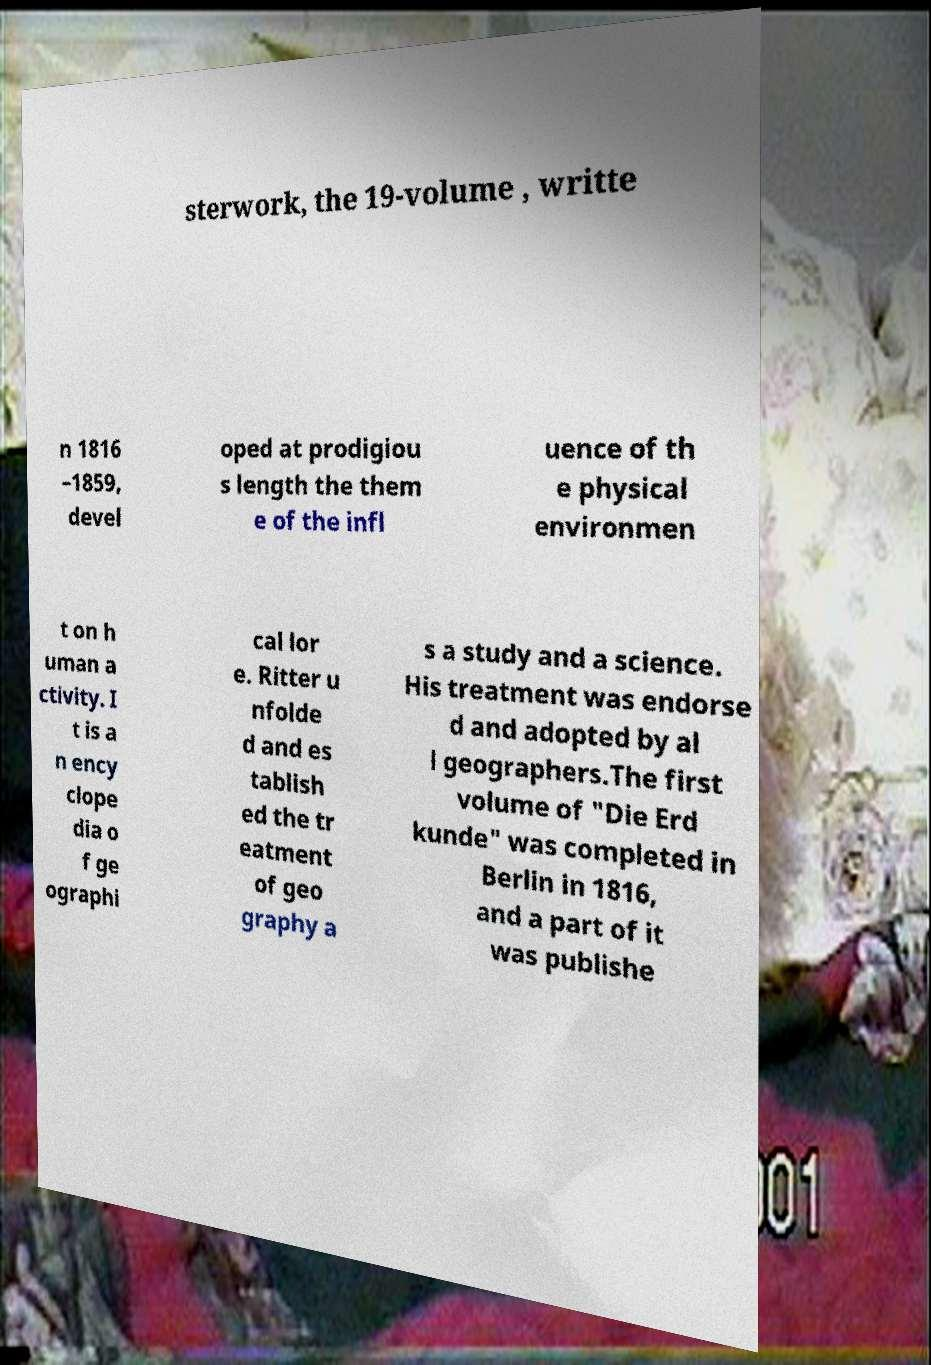Could you assist in decoding the text presented in this image and type it out clearly? sterwork, the 19-volume , writte n 1816 –1859, devel oped at prodigiou s length the them e of the infl uence of th e physical environmen t on h uman a ctivity. I t is a n ency clope dia o f ge ographi cal lor e. Ritter u nfolde d and es tablish ed the tr eatment of geo graphy a s a study and a science. His treatment was endorse d and adopted by al l geographers.The first volume of "Die Erd kunde" was completed in Berlin in 1816, and a part of it was publishe 